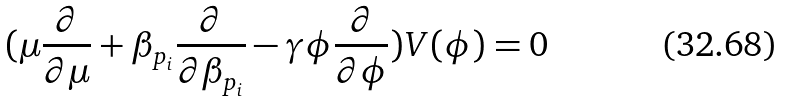<formula> <loc_0><loc_0><loc_500><loc_500>( \mu \frac { \partial } { \partial \mu } + \beta _ { p _ { i } } \frac { \partial } { \partial \beta _ { p _ { i } } } - \gamma \phi \frac { \partial } { \partial \phi } ) V ( \phi ) = 0</formula> 